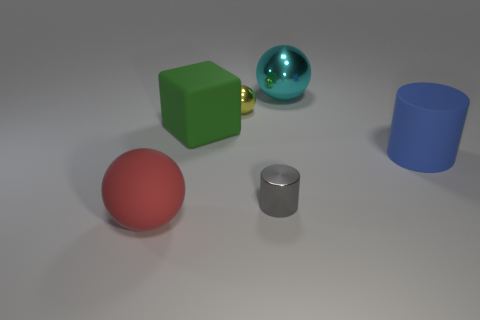What shape is the big thing that is both in front of the yellow ball and behind the big cylinder? The object you're referring to is a cube. It's a three-dimensional shape with six square faces, all of which are equal in size. In the image, the cube appears in a vivid green color, positioned between the shiny yellow sphere and the blue cylindrical shape. 